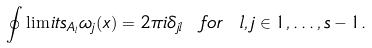Convert formula to latex. <formula><loc_0><loc_0><loc_500><loc_500>\oint \lim i t s _ { A _ { l } } \omega _ { j } ( x ) = 2 \pi i \delta _ { j l } \ f o r \ l , j \in { 1 , \dots , s - 1 } .</formula> 